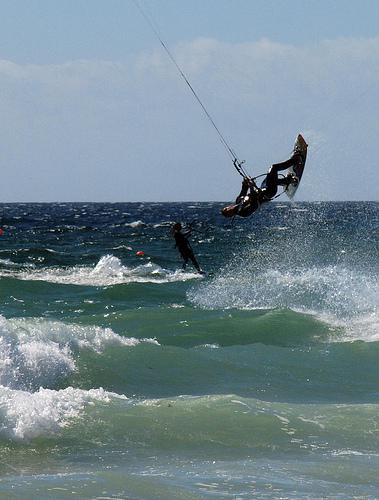Question: where was the photo taken?
Choices:
A. The ocean.
B. Patio.
C. The highway.
D. In the car.
Answer with the letter. Answer: A Question: what are the people doing?
Choices:
A. Sleeping.
B. Watching television.
C. Cooking food.
D. Surfing.
Answer with the letter. Answer: D Question: what was the weather like?
Choices:
A. Grim.
B. Clear.
C. Sunny.
D. Cloudy.
Answer with the letter. Answer: C 